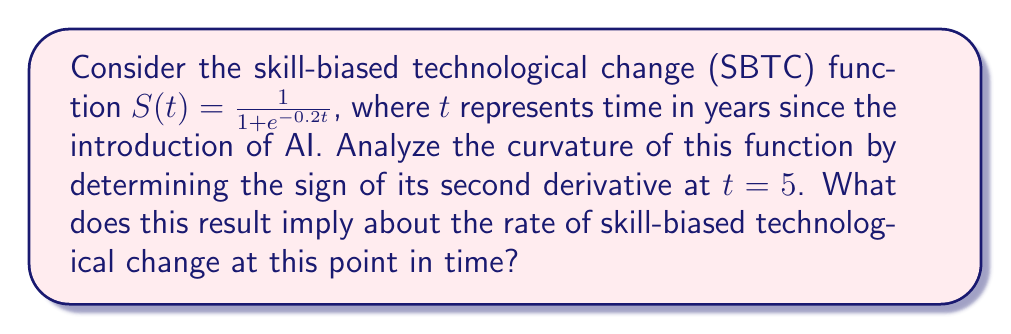Provide a solution to this math problem. To analyze the curvature of the SBTC function, we need to find its second derivative and evaluate its sign at $t = 5$. Let's proceed step-by-step:

1) First, let's find the first derivative of $S(t)$:
   $$S'(t) = \frac{d}{dt}\left(\frac{1}{1 + e^{-0.2t}}\right)$$
   Using the chain rule:
   $$S'(t) = \frac{0.2e^{-0.2t}}{(1 + e^{-0.2t})^2}$$

2) Now, let's find the second derivative by differentiating $S'(t)$:
   $$S''(t) = \frac{d}{dt}\left(\frac{0.2e^{-0.2t}}{(1 + e^{-0.2t})^2}\right)$$
   Using the quotient rule:
   $$S''(t) = \frac{-0.04e^{-0.2t}(1 + e^{-0.2t})^2 - 0.2e^{-0.2t} \cdot 2(1 + e^{-0.2t})(-0.2e^{-0.2t})}{(1 + e^{-0.2t})^4}$$
   Simplifying:
   $$S''(t) = \frac{0.04e^{-0.2t}(e^{-0.2t} - 1)}{(1 + e^{-0.2t})^3}$$

3) Now, let's evaluate $S''(5)$:
   $$S''(5) = \frac{0.04e^{-1}(e^{-1} - 1)}{(1 + e^{-1})^3}$$

4) We can see that:
   - $0.04 > 0$
   - $e^{-1} > 0$
   - $(e^{-1} - 1) < 0$ (since $e^{-1} \approx 0.368 < 1$)
   - $(1 + e^{-1})^3 > 0$

5) Therefore, $S''(5) < 0$

The negative second derivative at $t = 5$ implies that the SBTC function is concave down at this point. In the context of skill-biased technological change, this suggests that the rate of change in skill demand is decreasing at $t = 5$, indicating a slowing acceleration of skill-biased technological change 5 years after the introduction of AI.
Answer: $S''(5) < 0$; SBTC is concave down, indicating decreasing rate of skill demand change. 